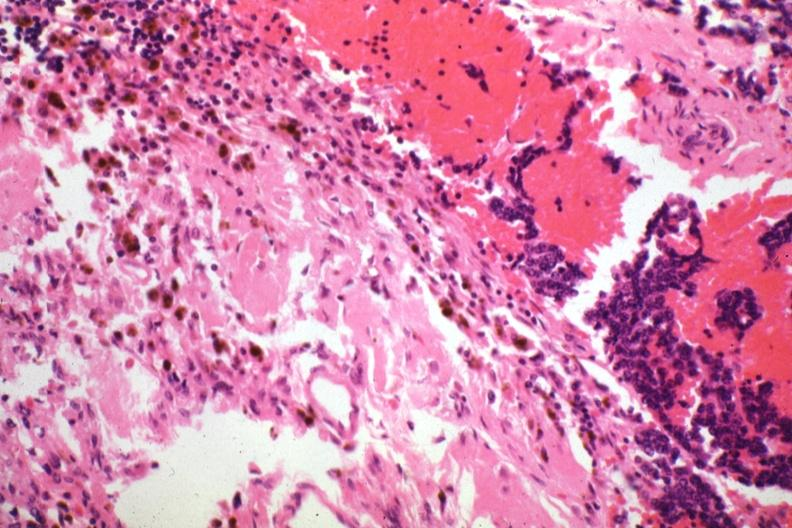s carcinomatosis endometrium primary present?
Answer the question using a single word or phrase. No 